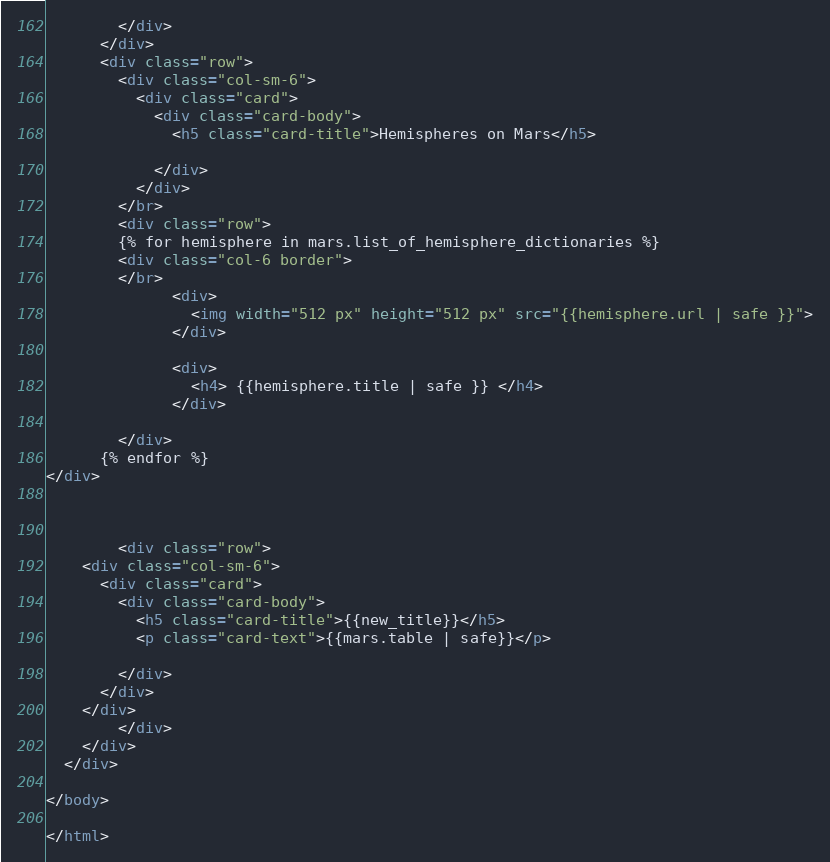<code> <loc_0><loc_0><loc_500><loc_500><_HTML_>        </div>
      </div>
      <div class="row">
        <div class="col-sm-6">
          <div class="card">
            <div class="card-body">
              <h5 class="card-title">Hemispheres on Mars</h5>
                           
            </div>
          </div>
        </br>
        <div class="row">
        {% for hemisphere in mars.list_of_hemisphere_dictionaries %} 
        <div class="col-6 border">
        </br>
              <div>
                <img width="512 px" height="512 px" src="{{hemisphere.url | safe }}">
              </div>

              <div>
                <h4> {{hemisphere.title | safe }} </h4>  
              </div>
      
        </div>
      {% endfor %}
</div> 



        <div class="row">
    <div class="col-sm-6">
      <div class="card">
        <div class="card-body">
          <h5 class="card-title">{{new_title}}</h5>
          <p class="card-text">{{mars.table | safe}}</p>
          
        </div>
      </div>
    </div>
        </div>
    </div>
  </div>

</body>

</html>



</code> 